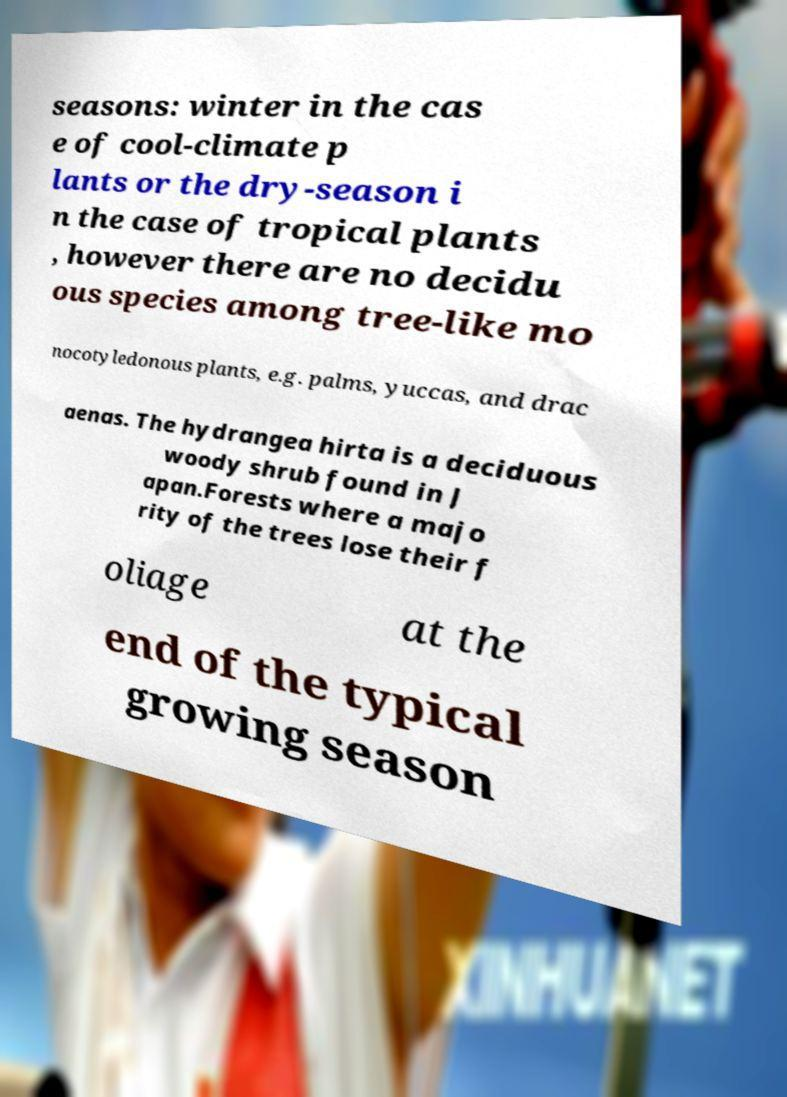There's text embedded in this image that I need extracted. Can you transcribe it verbatim? seasons: winter in the cas e of cool-climate p lants or the dry-season i n the case of tropical plants , however there are no decidu ous species among tree-like mo nocotyledonous plants, e.g. palms, yuccas, and drac aenas. The hydrangea hirta is a deciduous woody shrub found in J apan.Forests where a majo rity of the trees lose their f oliage at the end of the typical growing season 